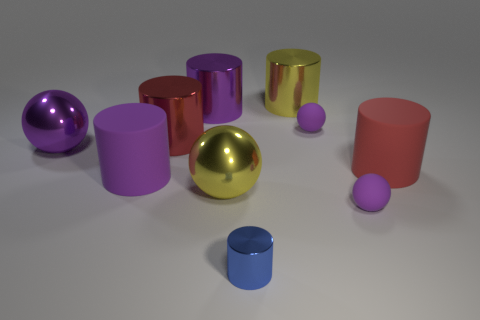Can you speculate on the purpose of this arrangement? Is it functional or purely aesthetic? The purpose of this arrangement seems purely aesthetic; it’s likely a 3D rendering designed to showcase the capabilities of computer-generated imagery or perhaps a visual study in shape, color, and light. Each object gleams with a distinct sheen, indicating different material properties, which suggests this could be an exercise in rendering materials and lighting. There's no indication of functionality in this context—it appears to be an artistic composition rather than a practical array of items. 